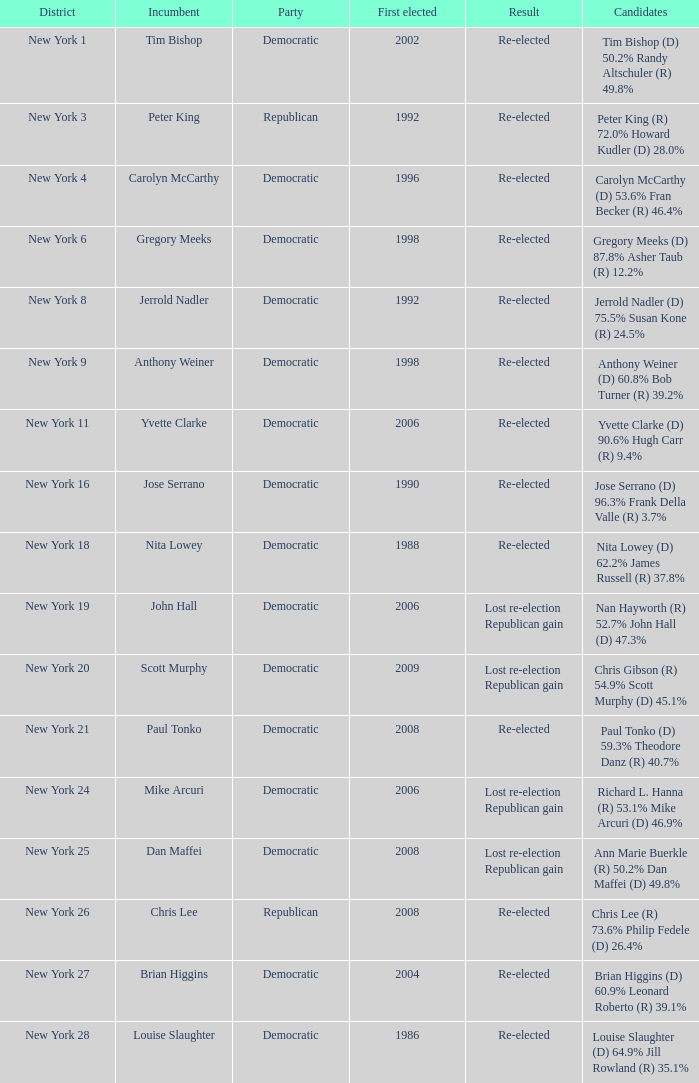Which party is associated with the 4th district of new york? Democratic. 